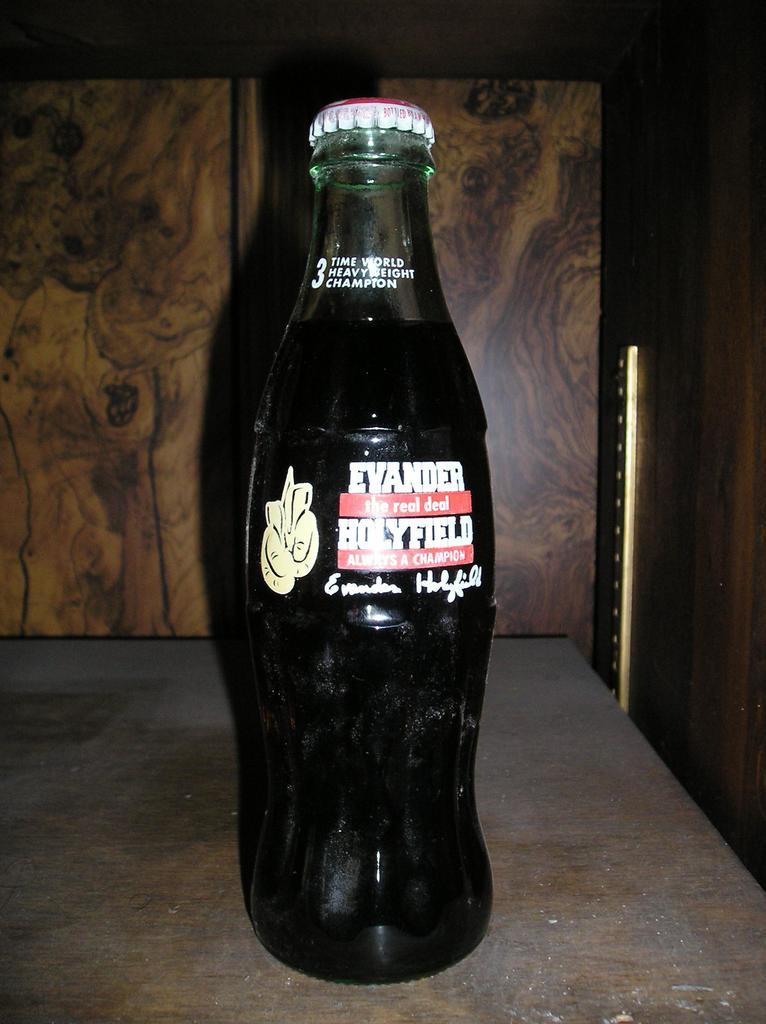What type of space is depicted in the image? There is a room in the image. What object can be seen on a table in the room? There is a bottle on a table in the room. Can you describe the bottle in more detail? The bottle has a sticker on it and a cap. What else can be seen in the background of the image? There is a cupboard visible in the background of the image. What type of harmony is being played in the room in the image? There is no indication of music or harmony being played in the room in the image. 